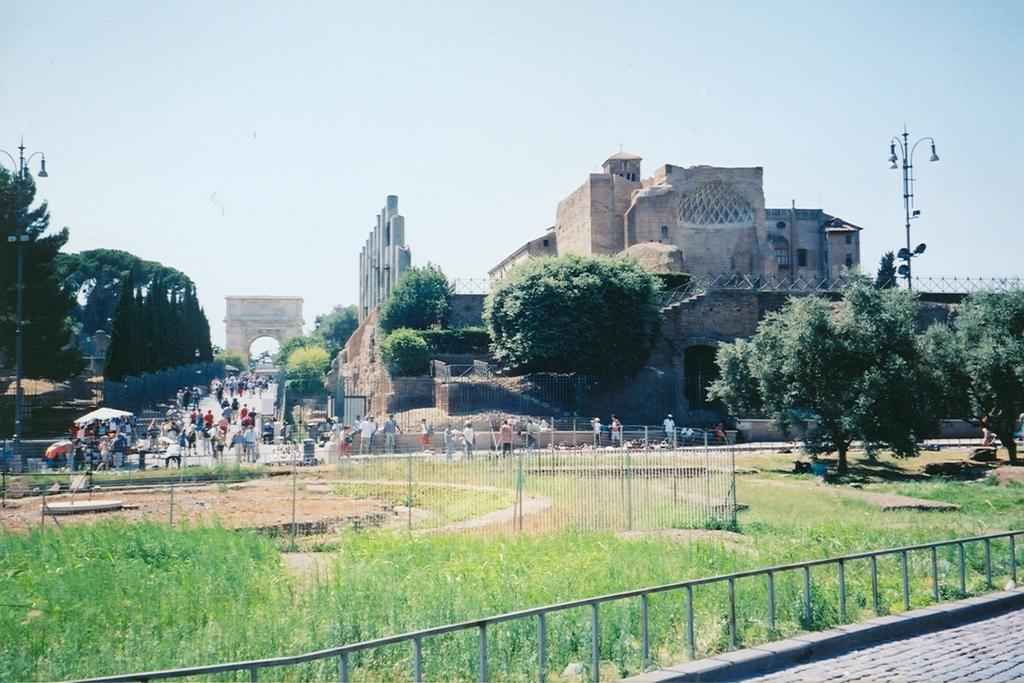What is the main structure in the image? There is a monument in the image. Who can be seen around the monument? There are visitors around the monument. What type of vegetation is present in the image? There are trees in the image. What objects are in front of the monument? There are poles in front of the monument. Reasoning: Let's think step by step by step in order to produce the conversation. We start by identifying the main subject in the image, which is the monument. Then, we expand the conversation to include other elements that are also visible, such as the visitors, trees, and poles. Each question is designed to elicit a specific detail about the image that is known from the provided facts. Absurd Question/Answer: Can you tell me how many deer are visible in the image? There are no deer present in the image. What type of care is being provided to the monument in the image? There is no indication of care being provided to the monument in the image. 